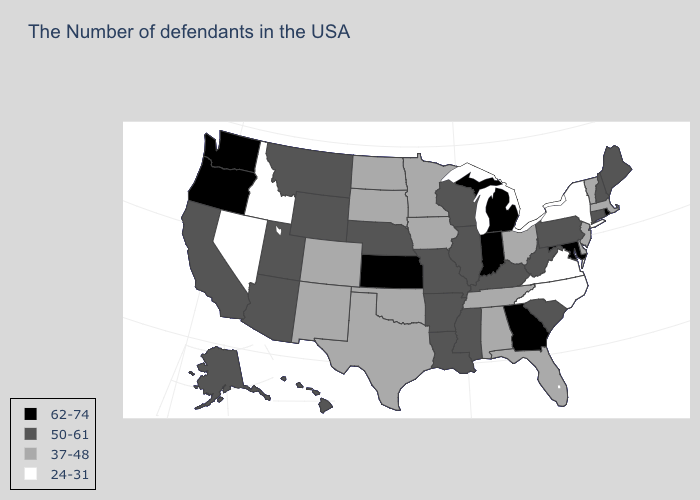What is the value of Louisiana?
Write a very short answer. 50-61. Name the states that have a value in the range 24-31?
Write a very short answer. New York, Virginia, North Carolina, Idaho, Nevada. What is the lowest value in the USA?
Answer briefly. 24-31. Name the states that have a value in the range 24-31?
Answer briefly. New York, Virginia, North Carolina, Idaho, Nevada. What is the lowest value in the South?
Give a very brief answer. 24-31. What is the value of Hawaii?
Give a very brief answer. 50-61. What is the lowest value in states that border Rhode Island?
Keep it brief. 37-48. Which states have the lowest value in the MidWest?
Give a very brief answer. Ohio, Minnesota, Iowa, South Dakota, North Dakota. Does the first symbol in the legend represent the smallest category?
Keep it brief. No. Does Maryland have the highest value in the South?
Short answer required. Yes. Does Louisiana have the lowest value in the USA?
Keep it brief. No. What is the lowest value in the South?
Answer briefly. 24-31. Is the legend a continuous bar?
Keep it brief. No. How many symbols are there in the legend?
Keep it brief. 4. 